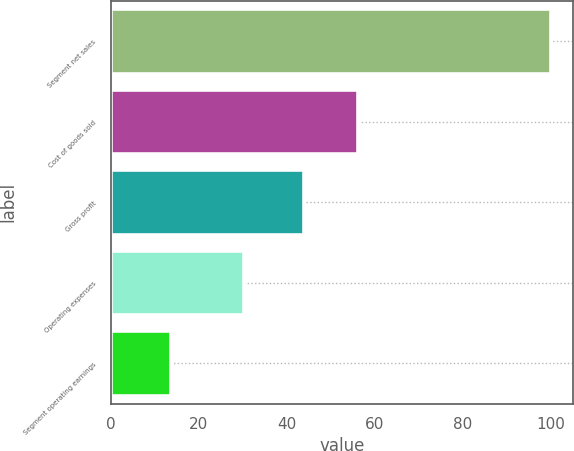<chart> <loc_0><loc_0><loc_500><loc_500><bar_chart><fcel>Segment net sales<fcel>Cost of goods sold<fcel>Gross profit<fcel>Operating expenses<fcel>Segment operating earnings<nl><fcel>100<fcel>56.1<fcel>43.9<fcel>30.2<fcel>13.7<nl></chart> 